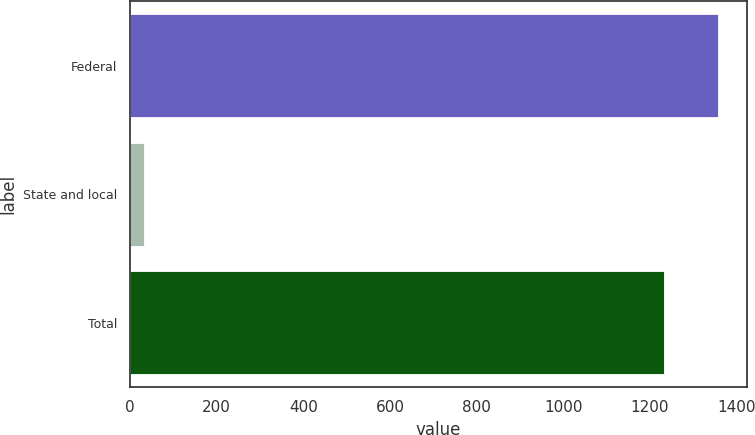Convert chart. <chart><loc_0><loc_0><loc_500><loc_500><bar_chart><fcel>Federal<fcel>State and local<fcel>Total<nl><fcel>1356.7<fcel>33<fcel>1233<nl></chart> 